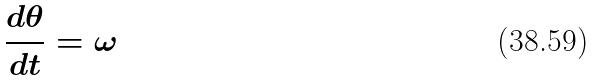Convert formula to latex. <formula><loc_0><loc_0><loc_500><loc_500>\frac { d \theta } { d t } = \omega</formula> 